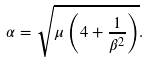Convert formula to latex. <formula><loc_0><loc_0><loc_500><loc_500>\alpha = \sqrt { \mu \left ( 4 + \frac { 1 } { \beta ^ { 2 } } \right ) } .</formula> 